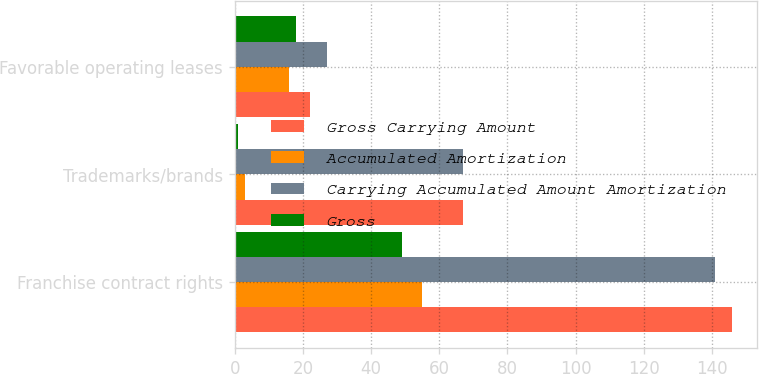Convert chart. <chart><loc_0><loc_0><loc_500><loc_500><stacked_bar_chart><ecel><fcel>Franchise contract rights<fcel>Trademarks/brands<fcel>Favorable operating leases<nl><fcel>Gross Carrying Amount<fcel>146<fcel>67<fcel>22<nl><fcel>Accumulated Amortization<fcel>55<fcel>3<fcel>16<nl><fcel>Carrying Accumulated Amount Amortization<fcel>141<fcel>67<fcel>27<nl><fcel>Gross<fcel>49<fcel>1<fcel>18<nl></chart> 